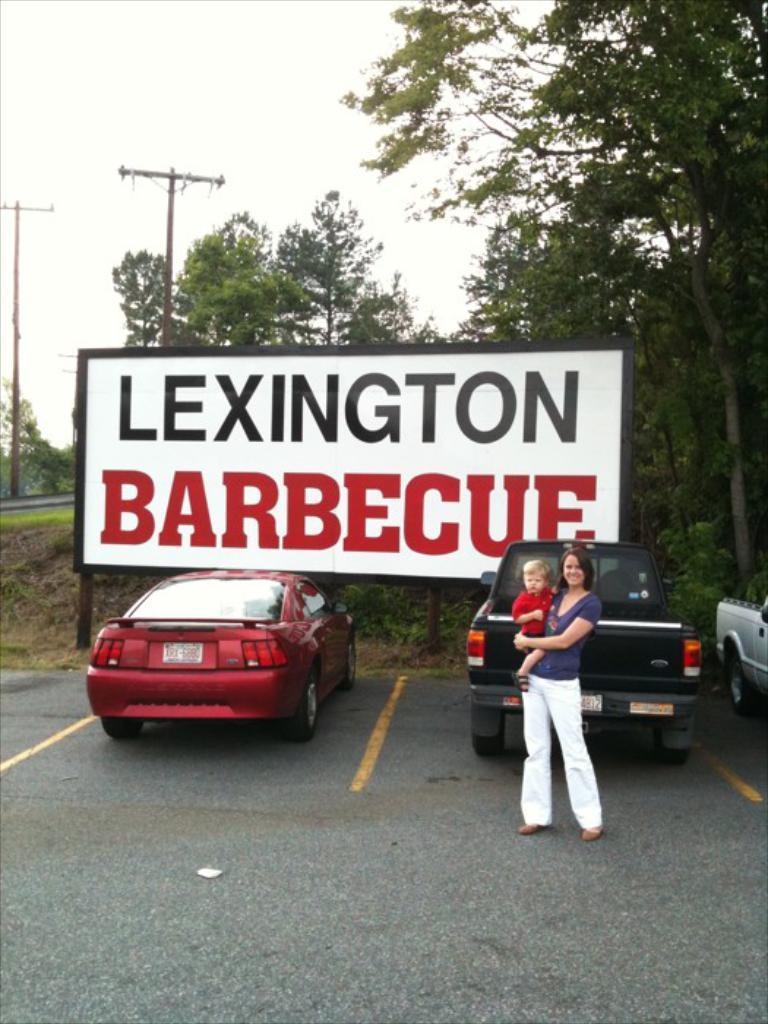Could you give a brief overview of what you see in this image? In this image I can see two cars which are maroon and black in color on the road and a woman wearing violet and white colored dress is standing and holding a baby who is wearing red colored dress. I can see a huge board which is white in color. In the background I can see few trees, few poles and the sky. 